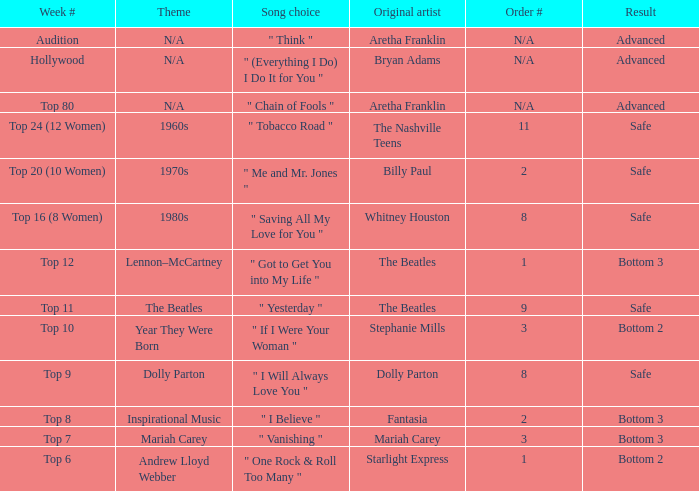Name the week number for andrew lloyd webber Top 6. 